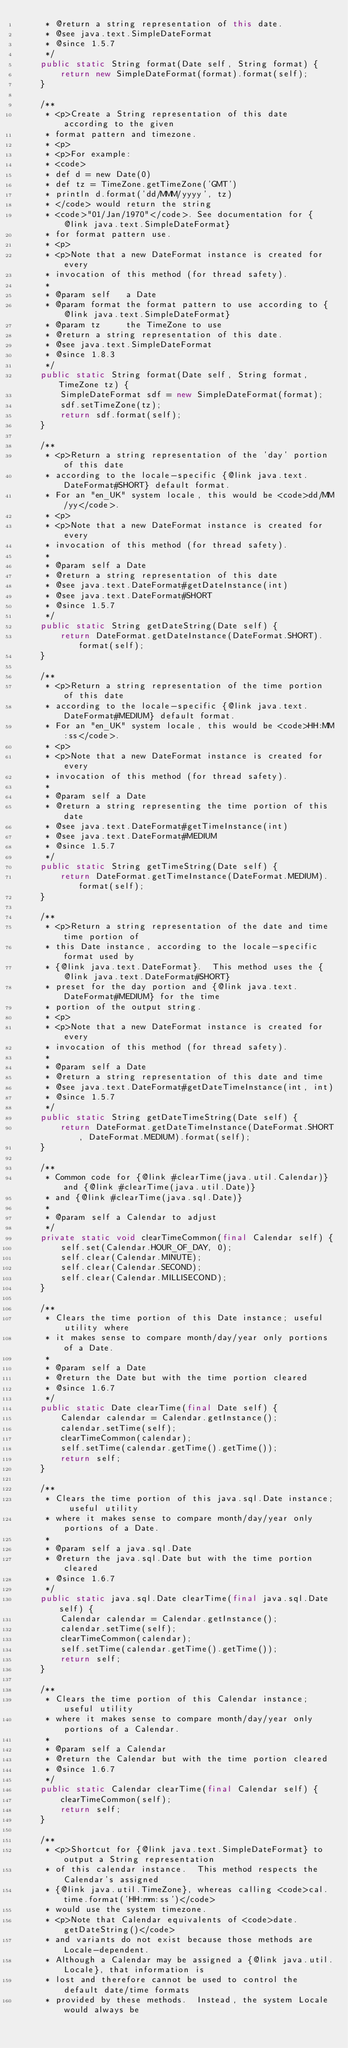<code> <loc_0><loc_0><loc_500><loc_500><_Java_>     * @return a string representation of this date.
     * @see java.text.SimpleDateFormat
     * @since 1.5.7
     */
    public static String format(Date self, String format) {
        return new SimpleDateFormat(format).format(self);
    }

    /**
     * <p>Create a String representation of this date according to the given
     * format pattern and timezone.
     * <p>
     * <p>For example:
     * <code>
     * def d = new Date(0)
     * def tz = TimeZone.getTimeZone('GMT')
     * println d.format('dd/MMM/yyyy', tz)
     * </code> would return the string
     * <code>"01/Jan/1970"</code>. See documentation for {@link java.text.SimpleDateFormat}
     * for format pattern use.
     * <p>
     * <p>Note that a new DateFormat instance is created for every
     * invocation of this method (for thread safety).
     *
     * @param self   a Date
     * @param format the format pattern to use according to {@link java.text.SimpleDateFormat}
     * @param tz     the TimeZone to use
     * @return a string representation of this date.
     * @see java.text.SimpleDateFormat
     * @since 1.8.3
     */
    public static String format(Date self, String format, TimeZone tz) {
        SimpleDateFormat sdf = new SimpleDateFormat(format);
        sdf.setTimeZone(tz);
        return sdf.format(self);
    }

    /**
     * <p>Return a string representation of the 'day' portion of this date
     * according to the locale-specific {@link java.text.DateFormat#SHORT} default format.
     * For an "en_UK" system locale, this would be <code>dd/MM/yy</code>.
     * <p>
     * <p>Note that a new DateFormat instance is created for every
     * invocation of this method (for thread safety).
     *
     * @param self a Date
     * @return a string representation of this date
     * @see java.text.DateFormat#getDateInstance(int)
     * @see java.text.DateFormat#SHORT
     * @since 1.5.7
     */
    public static String getDateString(Date self) {
        return DateFormat.getDateInstance(DateFormat.SHORT).format(self);
    }

    /**
     * <p>Return a string representation of the time portion of this date
     * according to the locale-specific {@link java.text.DateFormat#MEDIUM} default format.
     * For an "en_UK" system locale, this would be <code>HH:MM:ss</code>.
     * <p>
     * <p>Note that a new DateFormat instance is created for every
     * invocation of this method (for thread safety).
     *
     * @param self a Date
     * @return a string representing the time portion of this date
     * @see java.text.DateFormat#getTimeInstance(int)
     * @see java.text.DateFormat#MEDIUM
     * @since 1.5.7
     */
    public static String getTimeString(Date self) {
        return DateFormat.getTimeInstance(DateFormat.MEDIUM).format(self);
    }

    /**
     * <p>Return a string representation of the date and time time portion of
     * this Date instance, according to the locale-specific format used by
     * {@link java.text.DateFormat}.  This method uses the {@link java.text.DateFormat#SHORT}
     * preset for the day portion and {@link java.text.DateFormat#MEDIUM} for the time
     * portion of the output string.
     * <p>
     * <p>Note that a new DateFormat instance is created for every
     * invocation of this method (for thread safety).
     *
     * @param self a Date
     * @return a string representation of this date and time
     * @see java.text.DateFormat#getDateTimeInstance(int, int)
     * @since 1.5.7
     */
    public static String getDateTimeString(Date self) {
        return DateFormat.getDateTimeInstance(DateFormat.SHORT, DateFormat.MEDIUM).format(self);
    }

    /**
     * Common code for {@link #clearTime(java.util.Calendar)} and {@link #clearTime(java.util.Date)}
     * and {@link #clearTime(java.sql.Date)}
     *
     * @param self a Calendar to adjust
     */
    private static void clearTimeCommon(final Calendar self) {
        self.set(Calendar.HOUR_OF_DAY, 0);
        self.clear(Calendar.MINUTE);
        self.clear(Calendar.SECOND);
        self.clear(Calendar.MILLISECOND);
    }

    /**
     * Clears the time portion of this Date instance; useful utility where
     * it makes sense to compare month/day/year only portions of a Date.
     *
     * @param self a Date
     * @return the Date but with the time portion cleared
     * @since 1.6.7
     */
    public static Date clearTime(final Date self) {
        Calendar calendar = Calendar.getInstance();
        calendar.setTime(self);
        clearTimeCommon(calendar);
        self.setTime(calendar.getTime().getTime());
        return self;
    }

    /**
     * Clears the time portion of this java.sql.Date instance; useful utility
     * where it makes sense to compare month/day/year only portions of a Date.
     *
     * @param self a java.sql.Date
     * @return the java.sql.Date but with the time portion cleared
     * @since 1.6.7
     */
    public static java.sql.Date clearTime(final java.sql.Date self) {
        Calendar calendar = Calendar.getInstance();
        calendar.setTime(self);
        clearTimeCommon(calendar);
        self.setTime(calendar.getTime().getTime());
        return self;
    }

    /**
     * Clears the time portion of this Calendar instance; useful utility
     * where it makes sense to compare month/day/year only portions of a Calendar.
     *
     * @param self a Calendar
     * @return the Calendar but with the time portion cleared
     * @since 1.6.7
     */
    public static Calendar clearTime(final Calendar self) {
        clearTimeCommon(self);
        return self;
    }

    /**
     * <p>Shortcut for {@link java.text.SimpleDateFormat} to output a String representation
     * of this calendar instance.  This method respects the Calendar's assigned
     * {@link java.util.TimeZone}, whereas calling <code>cal.time.format('HH:mm:ss')</code>
     * would use the system timezone.
     * <p>Note that Calendar equivalents of <code>date.getDateString()</code>
     * and variants do not exist because those methods are Locale-dependent.
     * Although a Calendar may be assigned a {@link java.util.Locale}, that information is
     * lost and therefore cannot be used to control the default date/time formats
     * provided by these methods.  Instead, the system Locale would always be</code> 